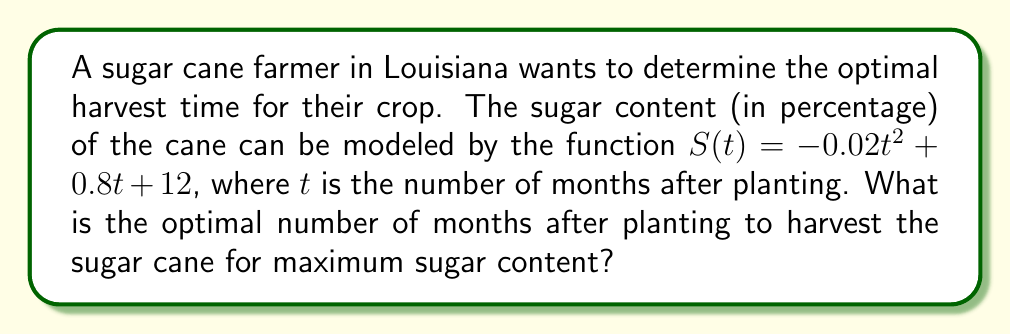Can you answer this question? To find the optimal harvest time, we need to determine the maximum point of the sugar content function $S(t)$. This can be done by following these steps:

1. The function $S(t) = -0.02t^2 + 0.8t + 12$ is a quadratic function.

2. For a quadratic function in the form $f(t) = at^2 + bt + c$, the t-coordinate of the vertex (which represents the maximum or minimum point) is given by $t = -\frac{b}{2a}$.

3. In our case, $a = -0.02$ and $b = 0.8$.

4. Substituting these values into the formula:

   $$t = -\frac{0.8}{2(-0.02)} = -\frac{0.8}{-0.04} = 20$$

5. To confirm this is a maximum (not a minimum), we can observe that $a = -0.02$ is negative, indicating the parabola opens downward and thus has a maximum point.

Therefore, the optimal time to harvest is 20 months after planting, when the sugar content will be at its maximum.
Answer: 20 months 